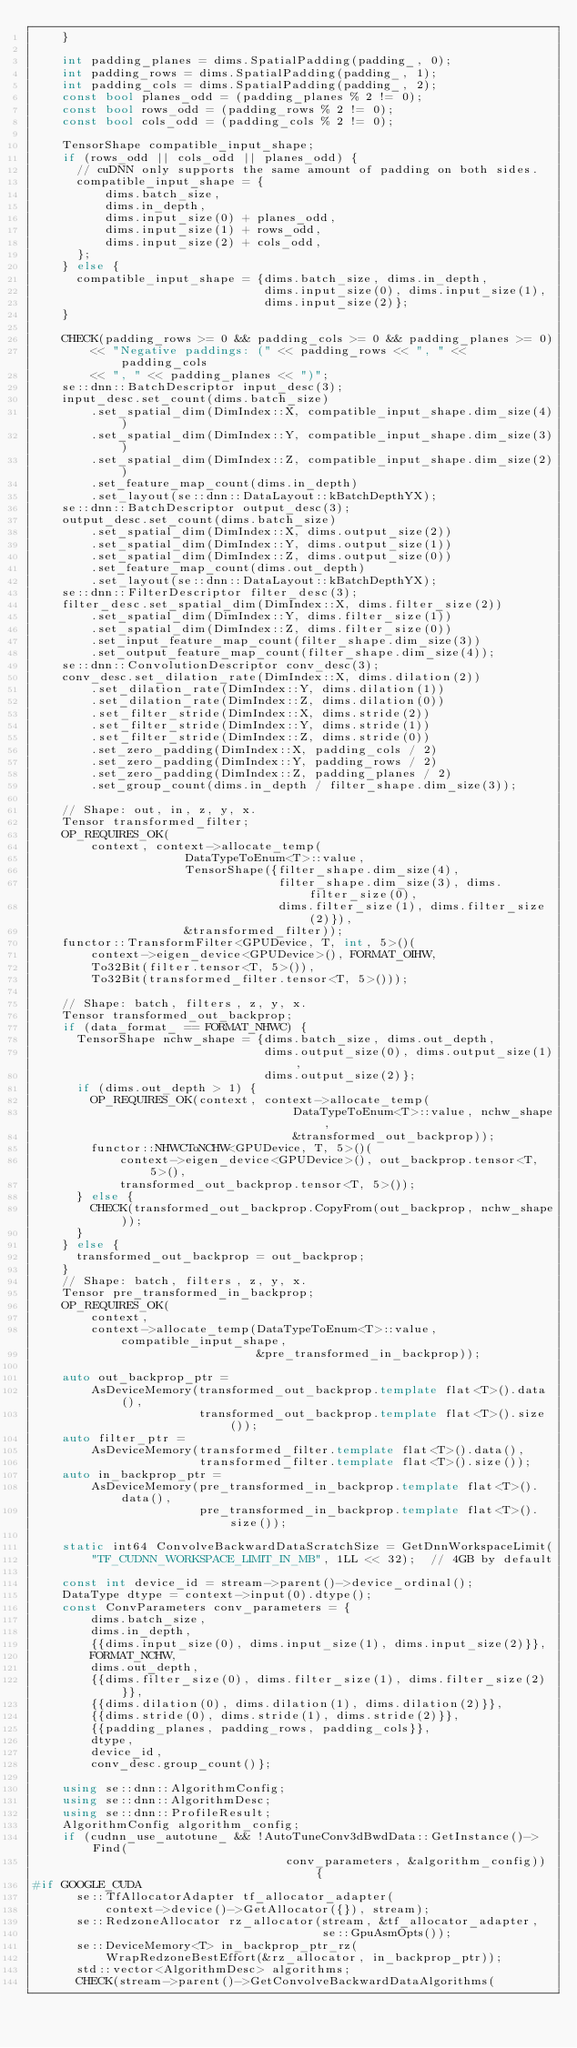<code> <loc_0><loc_0><loc_500><loc_500><_C++_>    }

    int padding_planes = dims.SpatialPadding(padding_, 0);
    int padding_rows = dims.SpatialPadding(padding_, 1);
    int padding_cols = dims.SpatialPadding(padding_, 2);
    const bool planes_odd = (padding_planes % 2 != 0);
    const bool rows_odd = (padding_rows % 2 != 0);
    const bool cols_odd = (padding_cols % 2 != 0);

    TensorShape compatible_input_shape;
    if (rows_odd || cols_odd || planes_odd) {
      // cuDNN only supports the same amount of padding on both sides.
      compatible_input_shape = {
          dims.batch_size,
          dims.in_depth,
          dims.input_size(0) + planes_odd,
          dims.input_size(1) + rows_odd,
          dims.input_size(2) + cols_odd,
      };
    } else {
      compatible_input_shape = {dims.batch_size, dims.in_depth,
                                dims.input_size(0), dims.input_size(1),
                                dims.input_size(2)};
    }

    CHECK(padding_rows >= 0 && padding_cols >= 0 && padding_planes >= 0)
        << "Negative paddings: (" << padding_rows << ", " << padding_cols
        << ", " << padding_planes << ")";
    se::dnn::BatchDescriptor input_desc(3);
    input_desc.set_count(dims.batch_size)
        .set_spatial_dim(DimIndex::X, compatible_input_shape.dim_size(4))
        .set_spatial_dim(DimIndex::Y, compatible_input_shape.dim_size(3))
        .set_spatial_dim(DimIndex::Z, compatible_input_shape.dim_size(2))
        .set_feature_map_count(dims.in_depth)
        .set_layout(se::dnn::DataLayout::kBatchDepthYX);
    se::dnn::BatchDescriptor output_desc(3);
    output_desc.set_count(dims.batch_size)
        .set_spatial_dim(DimIndex::X, dims.output_size(2))
        .set_spatial_dim(DimIndex::Y, dims.output_size(1))
        .set_spatial_dim(DimIndex::Z, dims.output_size(0))
        .set_feature_map_count(dims.out_depth)
        .set_layout(se::dnn::DataLayout::kBatchDepthYX);
    se::dnn::FilterDescriptor filter_desc(3);
    filter_desc.set_spatial_dim(DimIndex::X, dims.filter_size(2))
        .set_spatial_dim(DimIndex::Y, dims.filter_size(1))
        .set_spatial_dim(DimIndex::Z, dims.filter_size(0))
        .set_input_feature_map_count(filter_shape.dim_size(3))
        .set_output_feature_map_count(filter_shape.dim_size(4));
    se::dnn::ConvolutionDescriptor conv_desc(3);
    conv_desc.set_dilation_rate(DimIndex::X, dims.dilation(2))
        .set_dilation_rate(DimIndex::Y, dims.dilation(1))
        .set_dilation_rate(DimIndex::Z, dims.dilation(0))
        .set_filter_stride(DimIndex::X, dims.stride(2))
        .set_filter_stride(DimIndex::Y, dims.stride(1))
        .set_filter_stride(DimIndex::Z, dims.stride(0))
        .set_zero_padding(DimIndex::X, padding_cols / 2)
        .set_zero_padding(DimIndex::Y, padding_rows / 2)
        .set_zero_padding(DimIndex::Z, padding_planes / 2)
        .set_group_count(dims.in_depth / filter_shape.dim_size(3));

    // Shape: out, in, z, y, x.
    Tensor transformed_filter;
    OP_REQUIRES_OK(
        context, context->allocate_temp(
                     DataTypeToEnum<T>::value,
                     TensorShape({filter_shape.dim_size(4),
                                  filter_shape.dim_size(3), dims.filter_size(0),
                                  dims.filter_size(1), dims.filter_size(2)}),
                     &transformed_filter));
    functor::TransformFilter<GPUDevice, T, int, 5>()(
        context->eigen_device<GPUDevice>(), FORMAT_OIHW,
        To32Bit(filter.tensor<T, 5>()),
        To32Bit(transformed_filter.tensor<T, 5>()));

    // Shape: batch, filters, z, y, x.
    Tensor transformed_out_backprop;
    if (data_format_ == FORMAT_NHWC) {
      TensorShape nchw_shape = {dims.batch_size, dims.out_depth,
                                dims.output_size(0), dims.output_size(1),
                                dims.output_size(2)};
      if (dims.out_depth > 1) {
        OP_REQUIRES_OK(context, context->allocate_temp(
                                    DataTypeToEnum<T>::value, nchw_shape,
                                    &transformed_out_backprop));
        functor::NHWCToNCHW<GPUDevice, T, 5>()(
            context->eigen_device<GPUDevice>(), out_backprop.tensor<T, 5>(),
            transformed_out_backprop.tensor<T, 5>());
      } else {
        CHECK(transformed_out_backprop.CopyFrom(out_backprop, nchw_shape));
      }
    } else {
      transformed_out_backprop = out_backprop;
    }
    // Shape: batch, filters, z, y, x.
    Tensor pre_transformed_in_backprop;
    OP_REQUIRES_OK(
        context,
        context->allocate_temp(DataTypeToEnum<T>::value, compatible_input_shape,
                               &pre_transformed_in_backprop));

    auto out_backprop_ptr =
        AsDeviceMemory(transformed_out_backprop.template flat<T>().data(),
                       transformed_out_backprop.template flat<T>().size());
    auto filter_ptr =
        AsDeviceMemory(transformed_filter.template flat<T>().data(),
                       transformed_filter.template flat<T>().size());
    auto in_backprop_ptr =
        AsDeviceMemory(pre_transformed_in_backprop.template flat<T>().data(),
                       pre_transformed_in_backprop.template flat<T>().size());

    static int64 ConvolveBackwardDataScratchSize = GetDnnWorkspaceLimit(
        "TF_CUDNN_WORKSPACE_LIMIT_IN_MB", 1LL << 32);  // 4GB by default

    const int device_id = stream->parent()->device_ordinal();
    DataType dtype = context->input(0).dtype();
    const ConvParameters conv_parameters = {
        dims.batch_size,
        dims.in_depth,
        {{dims.input_size(0), dims.input_size(1), dims.input_size(2)}},
        FORMAT_NCHW,
        dims.out_depth,
        {{dims.filter_size(0), dims.filter_size(1), dims.filter_size(2)}},
        {{dims.dilation(0), dims.dilation(1), dims.dilation(2)}},
        {{dims.stride(0), dims.stride(1), dims.stride(2)}},
        {{padding_planes, padding_rows, padding_cols}},
        dtype,
        device_id,
        conv_desc.group_count()};

    using se::dnn::AlgorithmConfig;
    using se::dnn::AlgorithmDesc;
    using se::dnn::ProfileResult;
    AlgorithmConfig algorithm_config;
    if (cudnn_use_autotune_ && !AutoTuneConv3dBwdData::GetInstance()->Find(
                                   conv_parameters, &algorithm_config)) {
#if GOOGLE_CUDA
      se::TfAllocatorAdapter tf_allocator_adapter(
          context->device()->GetAllocator({}), stream);
      se::RedzoneAllocator rz_allocator(stream, &tf_allocator_adapter,
                                        se::GpuAsmOpts());
      se::DeviceMemory<T> in_backprop_ptr_rz(
          WrapRedzoneBestEffort(&rz_allocator, in_backprop_ptr));
      std::vector<AlgorithmDesc> algorithms;
      CHECK(stream->parent()->GetConvolveBackwardDataAlgorithms(</code> 